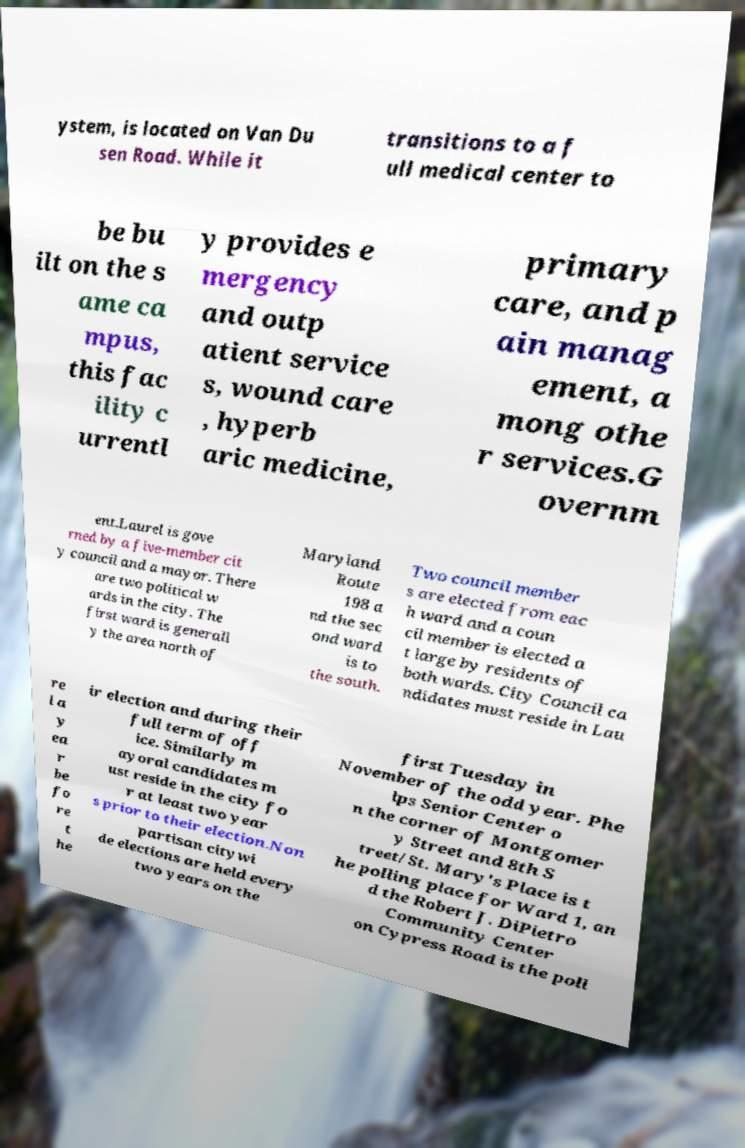There's text embedded in this image that I need extracted. Can you transcribe it verbatim? ystem, is located on Van Du sen Road. While it transitions to a f ull medical center to be bu ilt on the s ame ca mpus, this fac ility c urrentl y provides e mergency and outp atient service s, wound care , hyperb aric medicine, primary care, and p ain manag ement, a mong othe r services.G overnm ent.Laurel is gove rned by a five-member cit y council and a mayor. There are two political w ards in the city. The first ward is generall y the area north of Maryland Route 198 a nd the sec ond ward is to the south. Two council member s are elected from eac h ward and a coun cil member is elected a t large by residents of both wards. City Council ca ndidates must reside in Lau re l a y ea r be fo re t he ir election and during their full term of off ice. Similarly m ayoral candidates m ust reside in the city fo r at least two year s prior to their election.Non partisan citywi de elections are held every two years on the first Tuesday in November of the odd year. Phe lps Senior Center o n the corner of Montgomer y Street and 8th S treet/St. Mary's Place is t he polling place for Ward 1, an d the Robert J. DiPietro Community Center on Cypress Road is the poll 